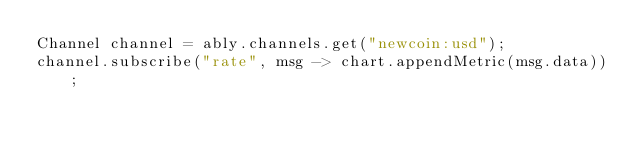<code> <loc_0><loc_0><loc_500><loc_500><_Java_>Channel channel = ably.channels.get("newcoin:usd");
channel.subscribe("rate", msg -> chart.appendMetric(msg.data));
</code> 